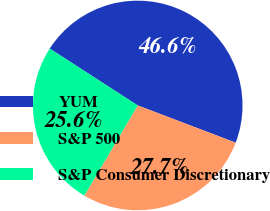Convert chart to OTSL. <chart><loc_0><loc_0><loc_500><loc_500><pie_chart><fcel>YUM<fcel>S&P 500<fcel>S&P Consumer Discretionary<nl><fcel>46.65%<fcel>27.73%<fcel>25.62%<nl></chart> 